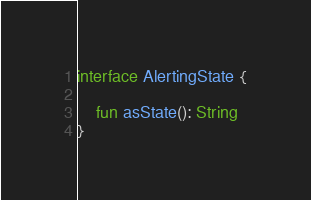<code> <loc_0><loc_0><loc_500><loc_500><_Kotlin_>
interface AlertingState {

    fun asState(): String
}
</code> 